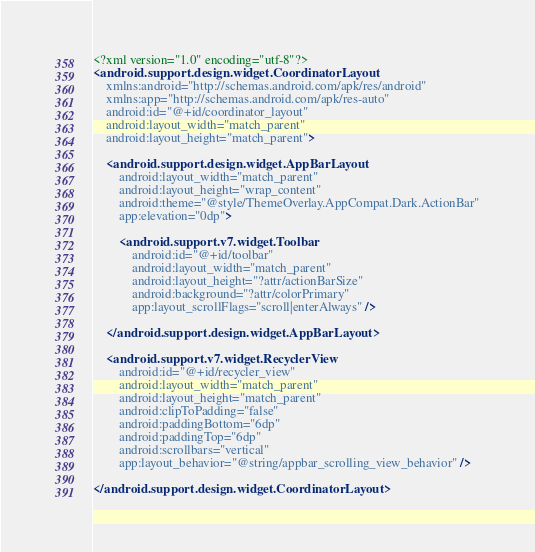<code> <loc_0><loc_0><loc_500><loc_500><_XML_><?xml version="1.0" encoding="utf-8"?>
<android.support.design.widget.CoordinatorLayout
    xmlns:android="http://schemas.android.com/apk/res/android"
    xmlns:app="http://schemas.android.com/apk/res-auto"
    android:id="@+id/coordinator_layout"
    android:layout_width="match_parent"
    android:layout_height="match_parent">

    <android.support.design.widget.AppBarLayout
        android:layout_width="match_parent"
        android:layout_height="wrap_content"
        android:theme="@style/ThemeOverlay.AppCompat.Dark.ActionBar"
        app:elevation="0dp">

        <android.support.v7.widget.Toolbar
            android:id="@+id/toolbar"
            android:layout_width="match_parent"
            android:layout_height="?attr/actionBarSize"
            android:background="?attr/colorPrimary"
            app:layout_scrollFlags="scroll|enterAlways" />

    </android.support.design.widget.AppBarLayout>

    <android.support.v7.widget.RecyclerView
        android:id="@+id/recycler_view"
        android:layout_width="match_parent"
        android:layout_height="match_parent"
        android:clipToPadding="false"
        android:paddingBottom="6dp"
        android:paddingTop="6dp"
        android:scrollbars="vertical"
        app:layout_behavior="@string/appbar_scrolling_view_behavior" />

</android.support.design.widget.CoordinatorLayout>
</code> 